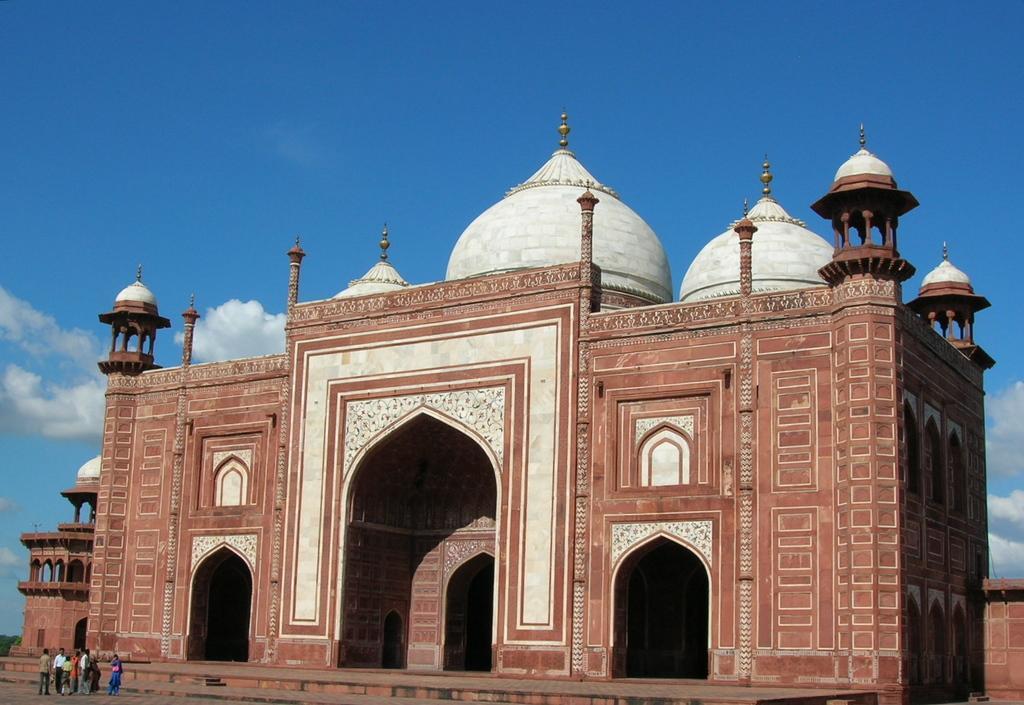Please provide a concise description of this image. In the center of the image we can see a monument with arches. At the bottom left side of the image, we can see a few people are standing. In the background, we can see the sky and clouds. 